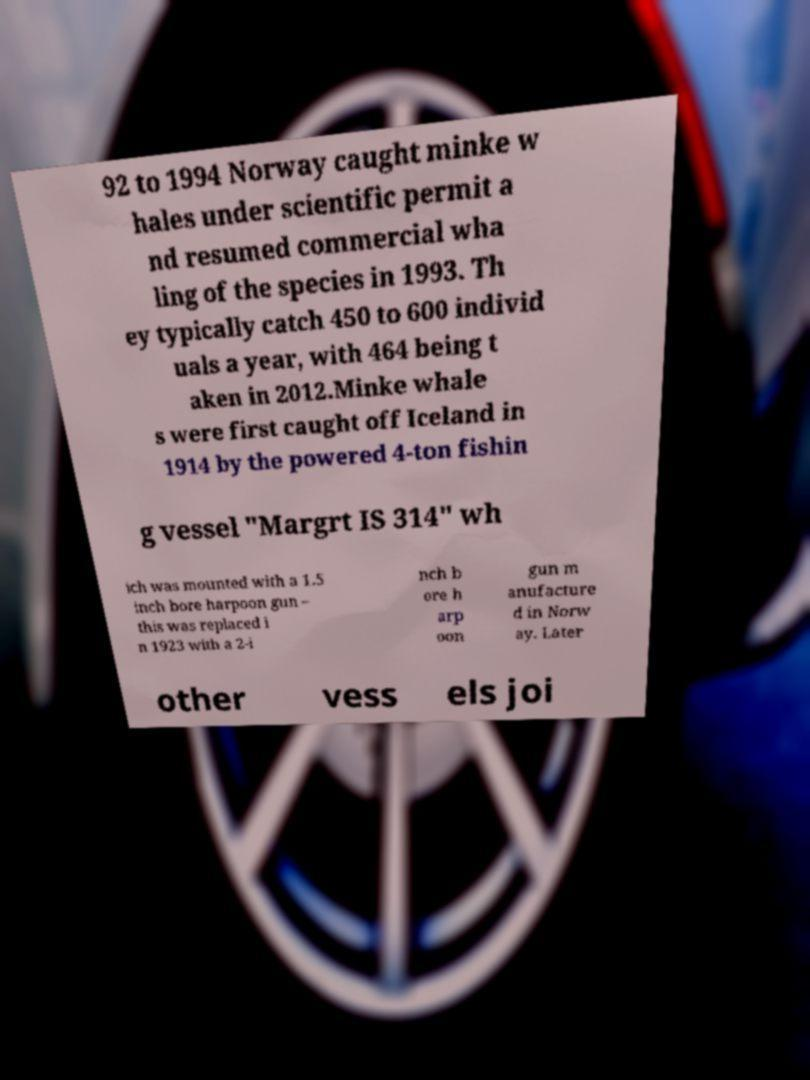Please identify and transcribe the text found in this image. 92 to 1994 Norway caught minke w hales under scientific permit a nd resumed commercial wha ling of the species in 1993. Th ey typically catch 450 to 600 individ uals a year, with 464 being t aken in 2012.Minke whale s were first caught off Iceland in 1914 by the powered 4-ton fishin g vessel "Margrt IS 314" wh ich was mounted with a 1.5 inch bore harpoon gun – this was replaced i n 1923 with a 2-i nch b ore h arp oon gun m anufacture d in Norw ay. Later other vess els joi 